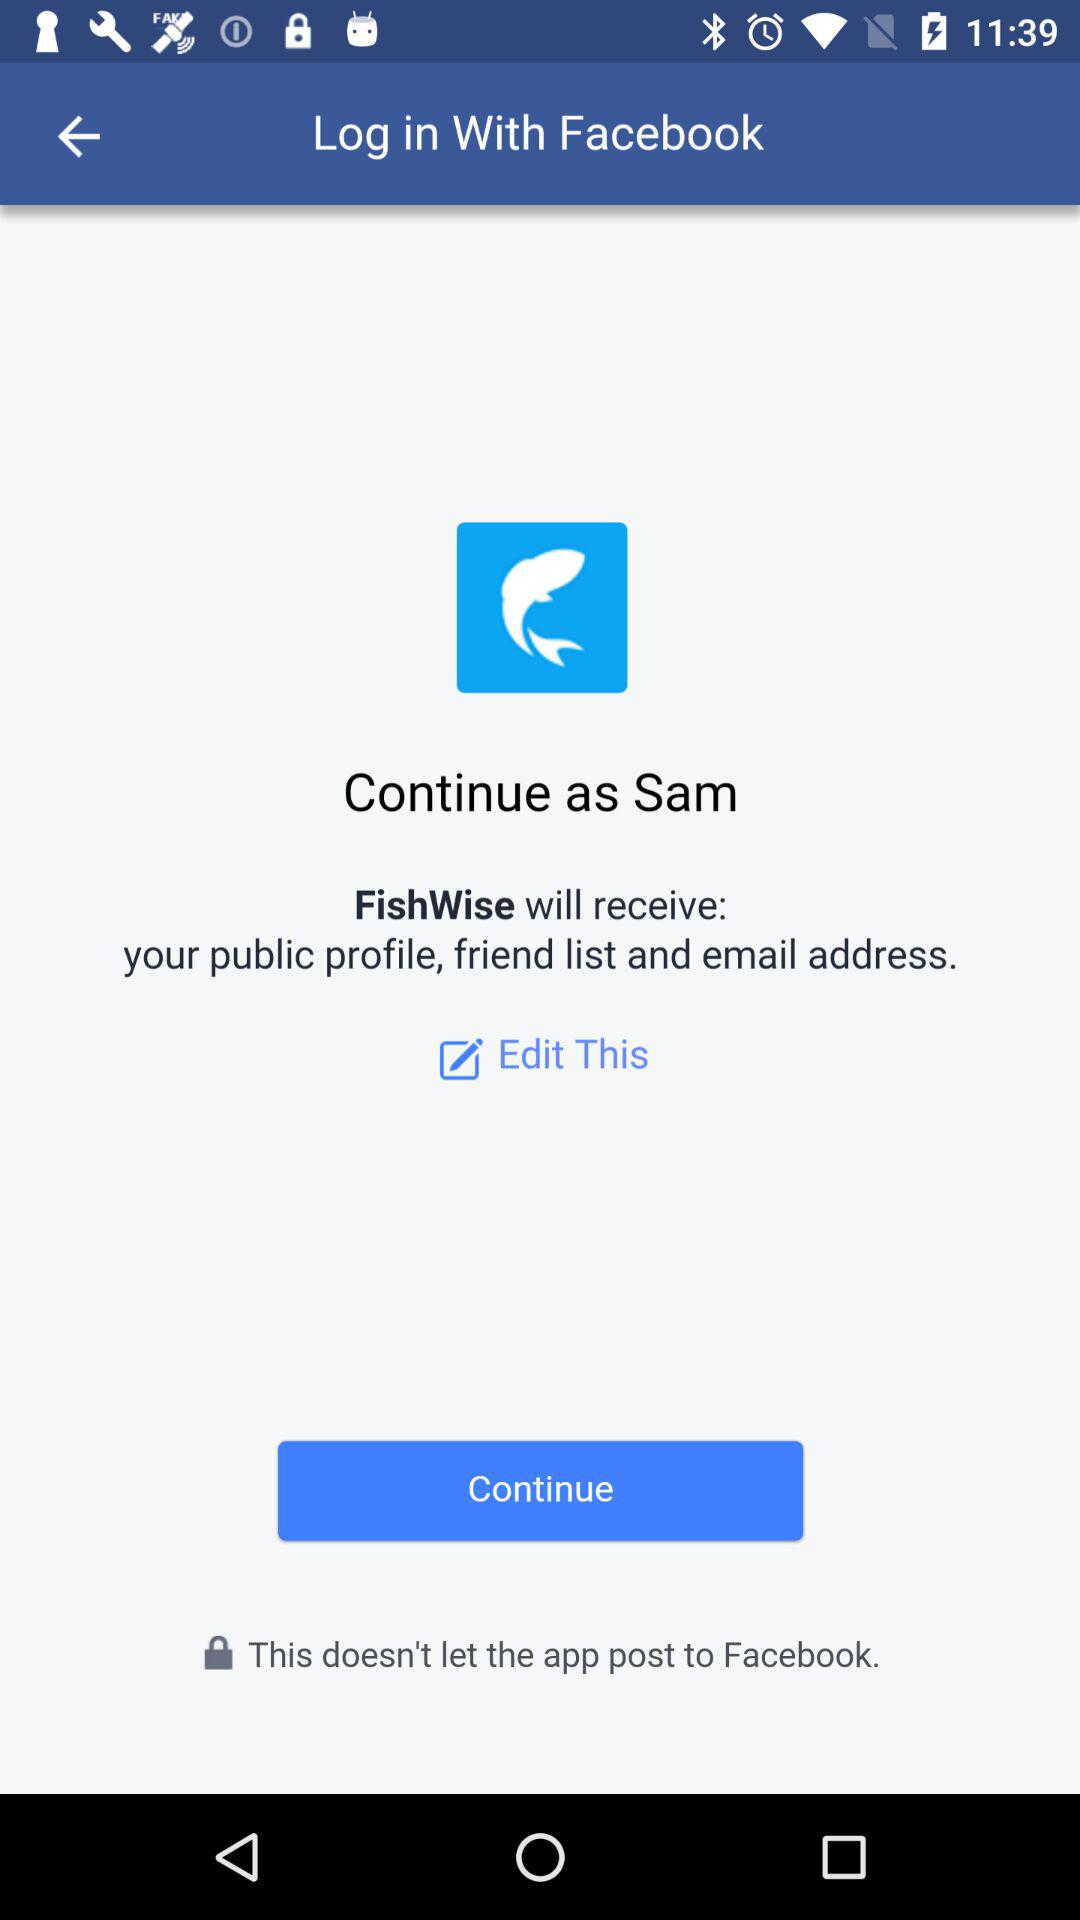Through what application is the person logging in? The person is logging in through "Facebook". 